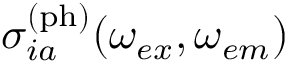Convert formula to latex. <formula><loc_0><loc_0><loc_500><loc_500>\sigma _ { i a } ^ { ( p h ) } ( \omega _ { e x } , \omega _ { e m } )</formula> 